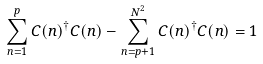Convert formula to latex. <formula><loc_0><loc_0><loc_500><loc_500>\sum _ { n = 1 } ^ { p } C ( n ) ^ { \dagger } C ( n ) - \sum _ { n = p + 1 } ^ { N ^ { 2 } } C ( n ) ^ { \dagger } C ( n ) = 1</formula> 